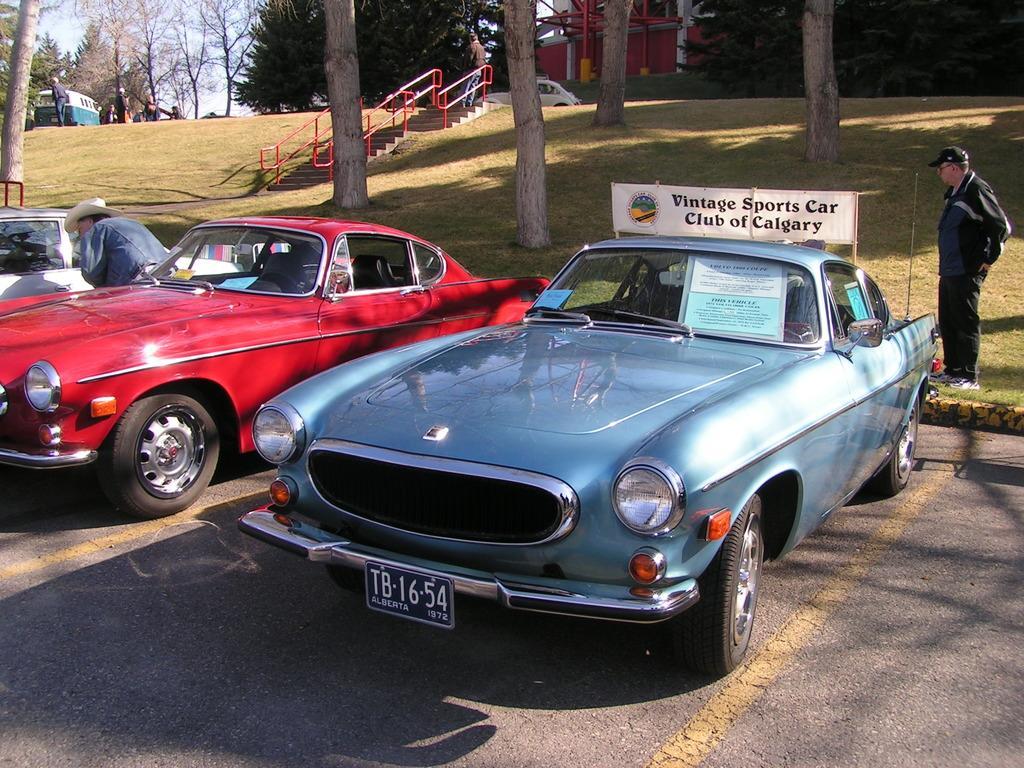Describe this image in one or two sentences. In this image I can see cars in the front. 2 men are standing. There are trees, grass and there are stairs and red railings in the center. There are people, trees, vehicles and buildings at the back. There is sky at the top. 